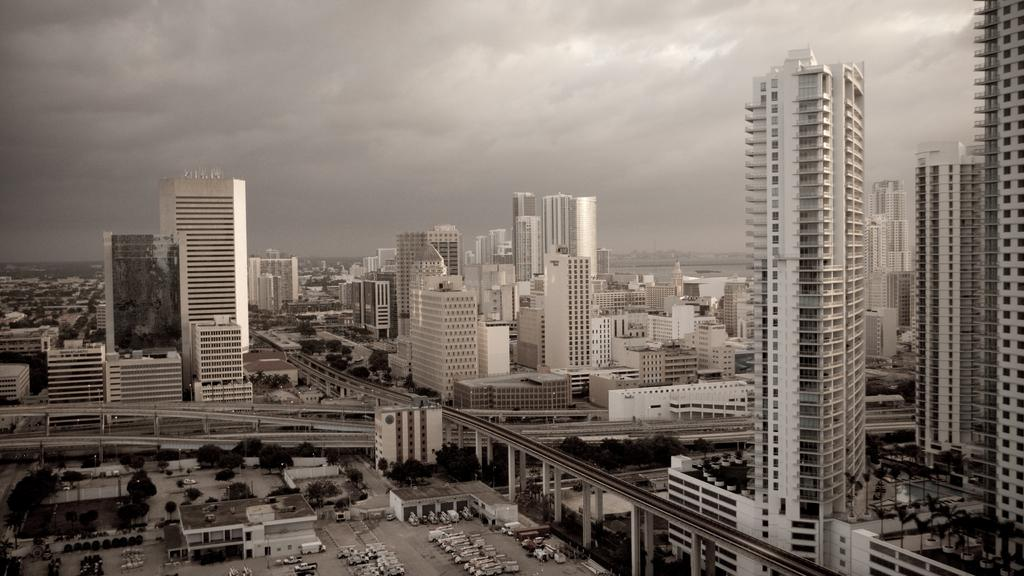What is the color scheme of the image? The image is black and white. What part of the natural environment can be seen in the image? The sky is visible in the image. What atmospheric conditions can be observed in the sky? Clouds are present in the sky. What type of structures are present in the image? There are buildings and skyscrapers in the image. What man-made objects are present in the image? Poles are visible in the image. What type of vegetation is present in the image? Trees are present in the image. What type of transportation infrastructure is present in the image? Roads are visible in the image. What type of vehicles can be seen on the roads in the image? Motor vehicles are on the floor in the image. What type of square is located on the roof of the tallest skyscraper in the image? There is no square present on the roof of any skyscraper in the image. Who is the owner of the loaf of bread seen on the sidewalk in the image? There is no loaf of bread present in the image. 